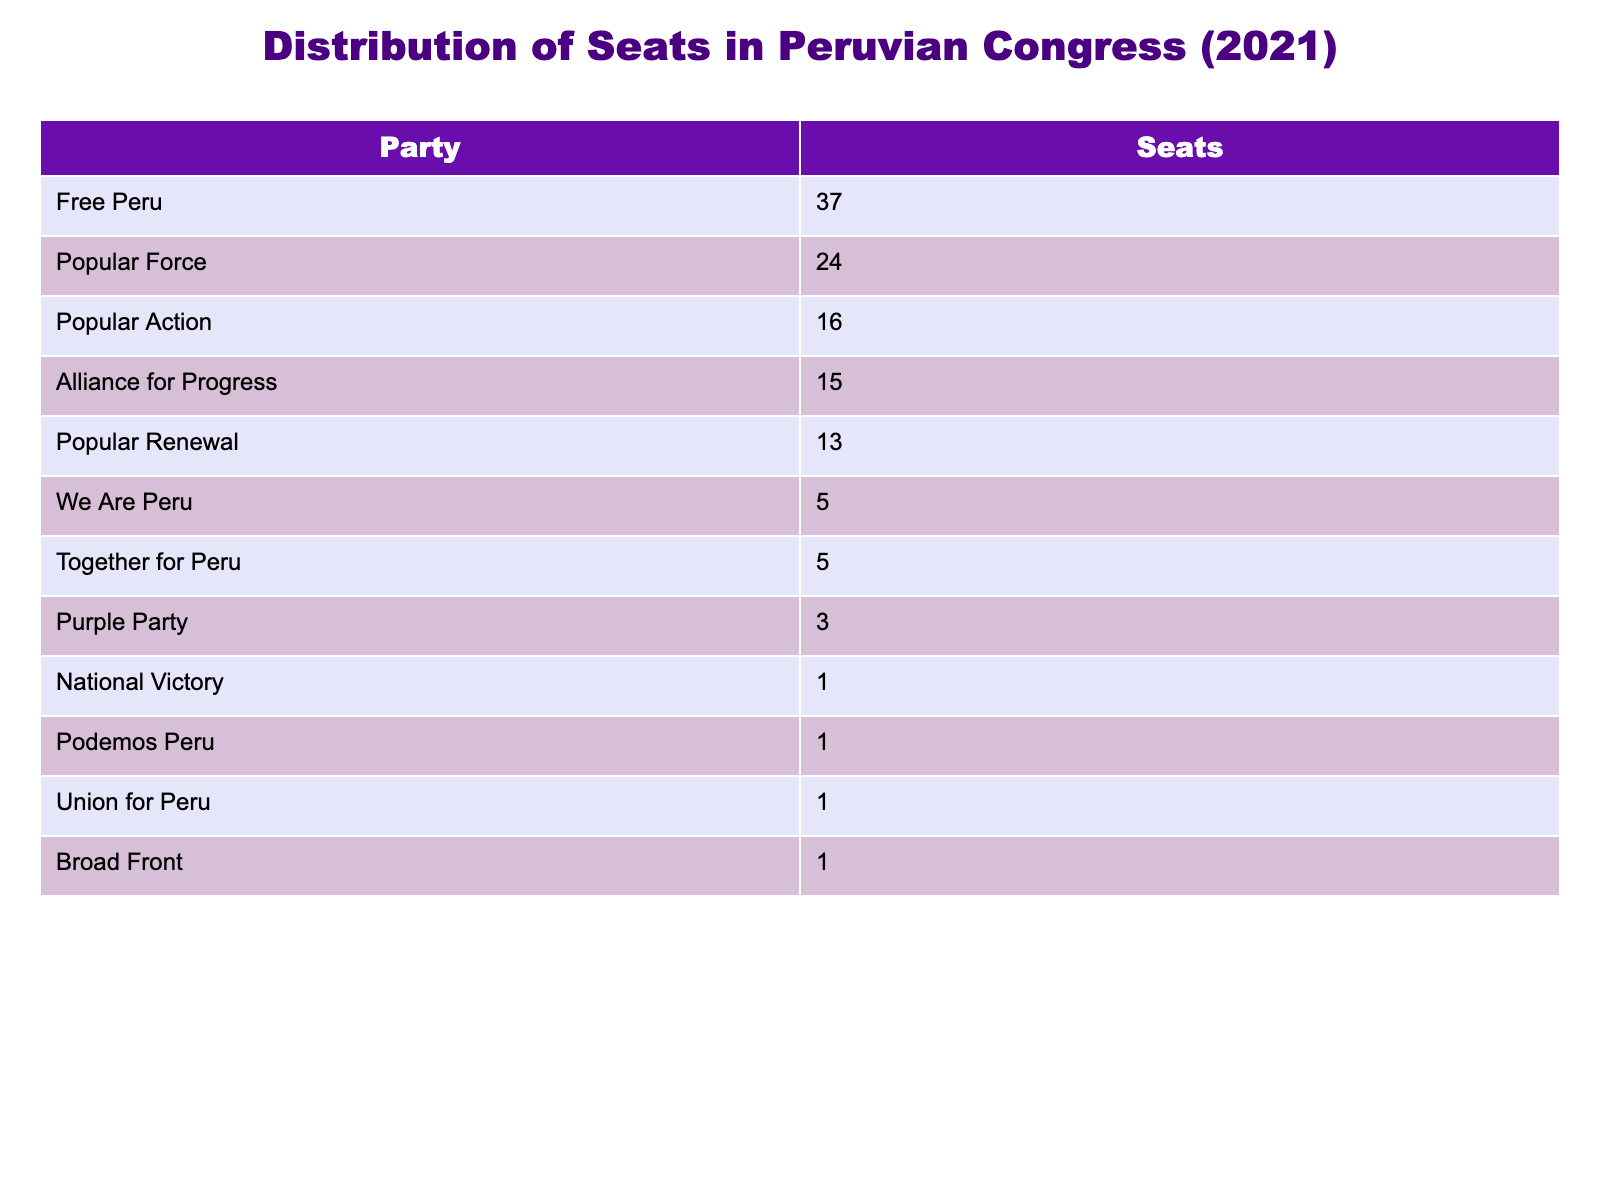What is the party with the most seats in the Peruvian Congress? Looking at the table, Free Peru has the highest number of seats, which is 37.
Answer: Free Peru How many seats does the Alliance for Progress hold? The table indicates that the Alliance for Progress has 15 seats in the Congress.
Answer: 15 What is the total number of seats held by the top three parties combined? Adding the seats of the top three parties: Free Peru (37) + Popular Force (24) + Popular Action (16) gives us a total of 77 seats.
Answer: 77 Which political party has the least number of seats, and how many do they have? The parties with the least number of seats are National Victory, Podemos Peru, Union for Peru, and Broad Front, each holding 1 seat.
Answer: National Victory, Podemos Peru, Union for Peru, Broad Front hold 1 seat each Is the number of seats held by the Popular Renewal greater than that of the Together for Peru? Popular Renewal has 13 seats, while Together for Peru has 5, meaning Popular Renewal has more seats.
Answer: Yes What is the difference in seats between Free Peru and the second-highest party? Free Peru has 37 seats and the second-highest, Popular Force, has 24 seats, creating a difference of 13 seats.
Answer: 13 What percentage of the total 130 seats in Congress does the Purple Party hold? The Purple Party has 3 seats; to find the percentage, (3/130) * 100 = approximately 2.31%.
Answer: 2.31% If you combine the seats of We Are Peru and Together for Peru, how many seats do they have together? We Are Peru has 5 seats and Together for Peru also has 5, so together they have 10 seats.
Answer: 10 Is the number of seats held by the Popular Action greater than the sum of the seats held by the Purple Party and the National Victory? Popular Action has 16 seats; the Purple Party has 3 and National Victory has 1, making their sum 4. 16 is greater than 4.
Answer: Yes Which two parties combined have more seats than the Popular Force? Popular Force has 24 seats. If you combine Alliance for Progress (15) and Popular Renewal (13), together they only have 28 seats, which is more than the Popular Force.
Answer: Alliance for Progress and Popular Renewal 